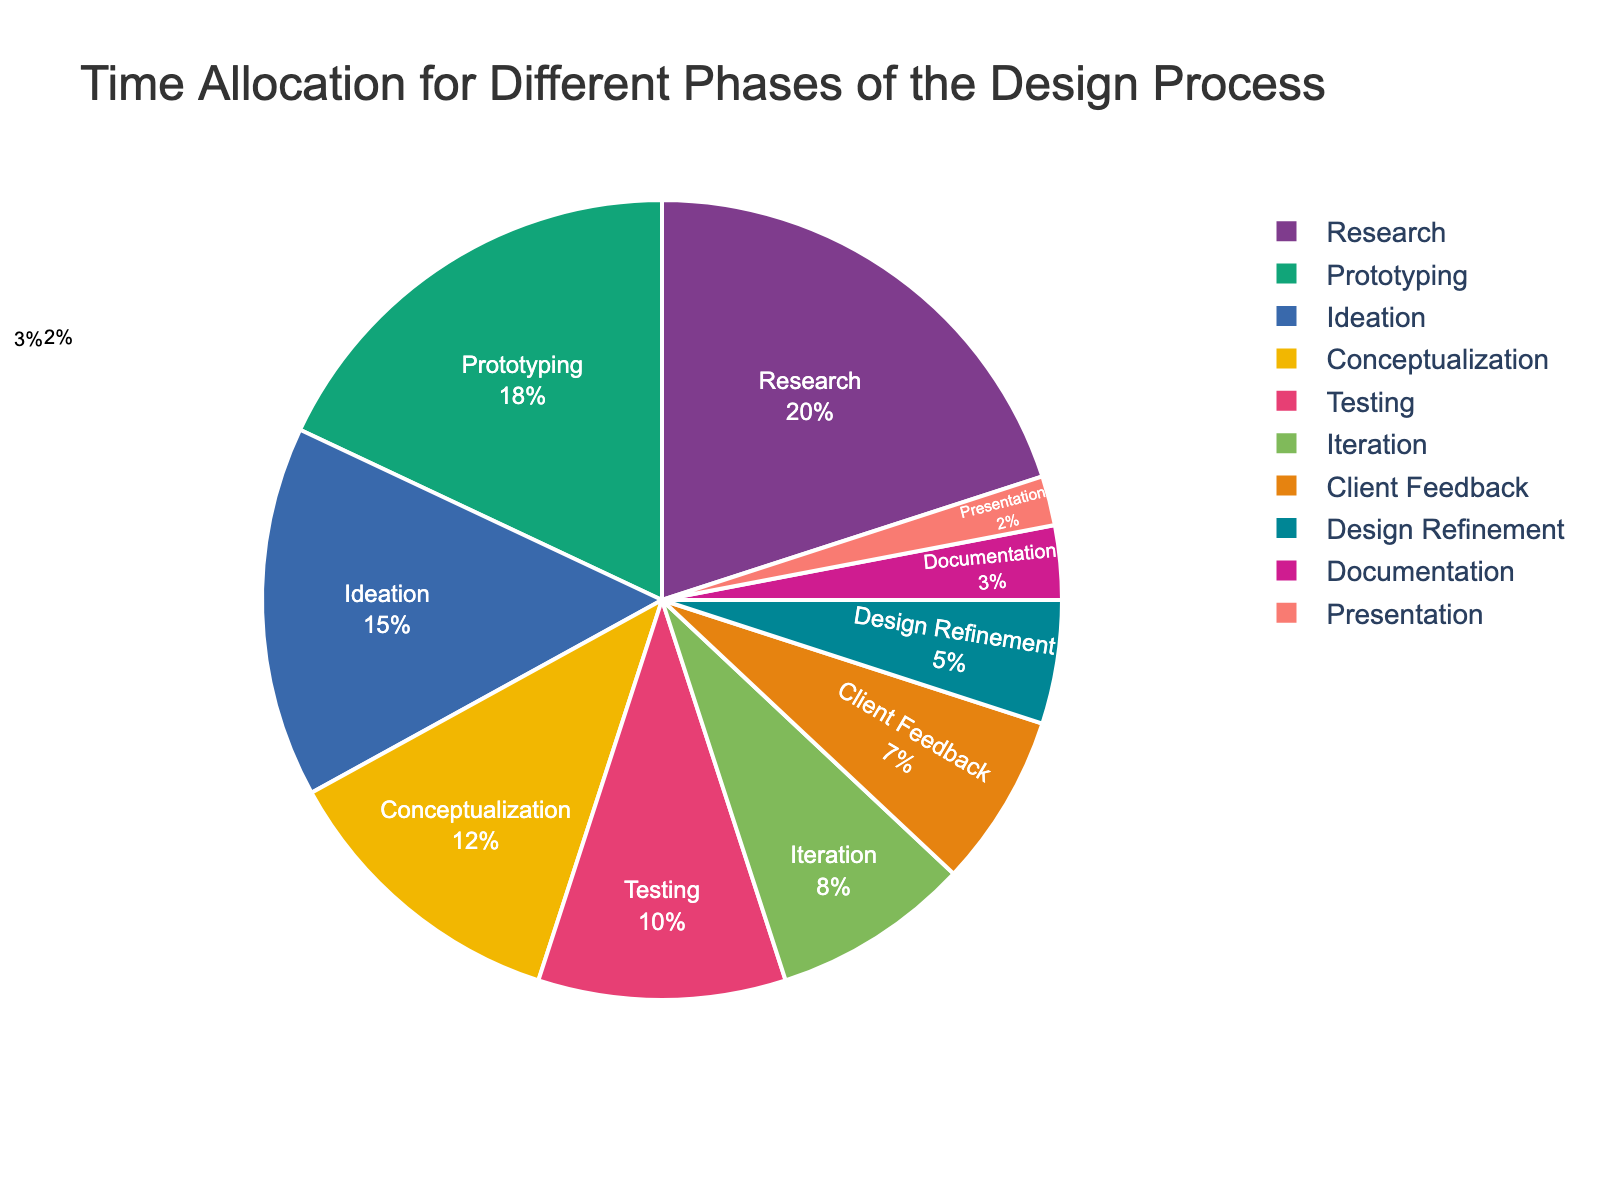What's the phase with the highest time allocation? By examining the pie chart, we see that the 'Research' phase has the largest slice. The text on the slice indicates that 'Research' accounts for 20% of the total time allocation, which is the highest among all phases.
Answer: Research Which phases collectively take up more than 50% of the total time allocation? The pie chart shows the following percentages for each phase: Research (20%), Ideation (15%), Prototyping (18%). Adding these three percentages gives 20% + 15% + 18% = 53%, which is more than 50%.
Answer: Research, Ideation, Prototyping How much more time is allocated to 'Prototyping' than 'Client Feedback'? The pie chart shows 'Prototyping' with 18% and 'Client Feedback' with 7%. The difference is calculated as 18% - 7% = 11%.
Answer: 11% Comparing 'Conceptualization' and 'Iteration', which phase takes up more time and by how much? 'Conceptualization' is allocated 12% and 'Iteration' is allocated 8%. The difference between these two phases is 12% - 8% = 4%. 'Conceptualization' takes up more time.
Answer: Conceptualization by 4% What is the combined percentage for 'Documentation' and 'Presentation'? The pie chart indicates 'Documentation' at 3% and 'Presentation' at 2%. The combined percentage is calculated as 3% + 2% = 5%.
Answer: 5% Which phase has the least time allocation and what is its percentage? The smallest slice on the pie chart represents 'Presentation', and the text indicates that its allocated time is 2%.
Answer: Presentation, 2% If 'Testing' and 'Iteration' were combined into one phase, what would their total time allocation be? 'Testing' is allocated 10% and 'Iteration' is allocated 8%. Adding these percentages gives 10% + 8% = 18%.
Answer: 18% Between 'Ideation' and 'Conceptualization', which phase has a larger time allocation and by what percentage difference? 'Ideation' is allocated 15%, while 'Conceptualization' is allocated 12%. The difference is calculated as 15% - 12% = 3%. 'Ideation' has a larger time allocation.
Answer: Ideation by 3% How much total time is allocated to phases directly dealing with client interaction (Client Feedback and Presentation)? The pie chart shows 'Client Feedback' at 7% and 'Presentation' at 2%. The combined time allocation is 7% + 2% = 9%.
Answer: 9% What is the proportion of time allocated to 'Iteration' compared to 'Research'? 'Iteration' is allocated 8% and 'Research' is allocated 20%. The proportion can be expressed as 8% / 20% = 0.4, indicating 'Iteration' is 40% of the time allocated to 'Research'.
Answer: 40% 